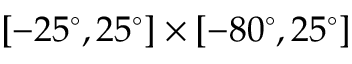<formula> <loc_0><loc_0><loc_500><loc_500>[ - 2 5 ^ { \circ } , 2 5 ^ { \circ } ] \times [ - 8 0 ^ { \circ } , 2 5 ^ { \circ } ]</formula> 